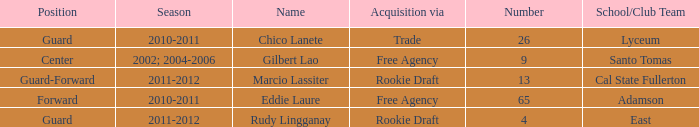What season had an acquisition of free agency, and was higher than 9? 2010-2011. 